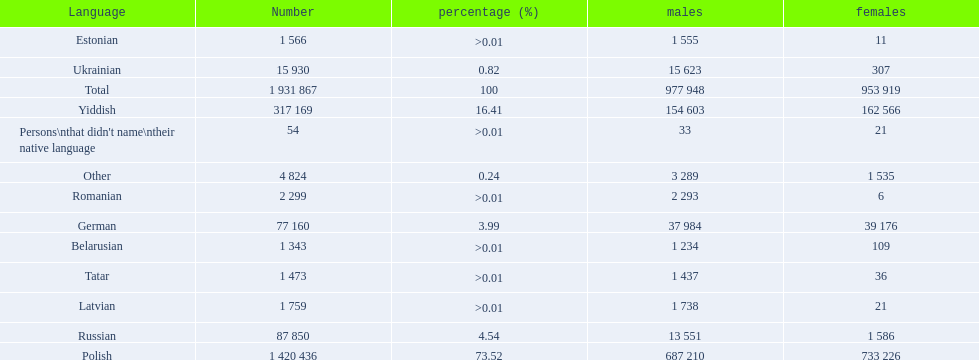What languages are spoken in the warsaw governorate? Polish, Yiddish, Russian, German, Ukrainian, Romanian, Latvian, Estonian, Tatar, Belarusian. Which are the top five languages? Polish, Yiddish, Russian, German, Ukrainian. Of those which is the 2nd most frequently spoken? Yiddish. 